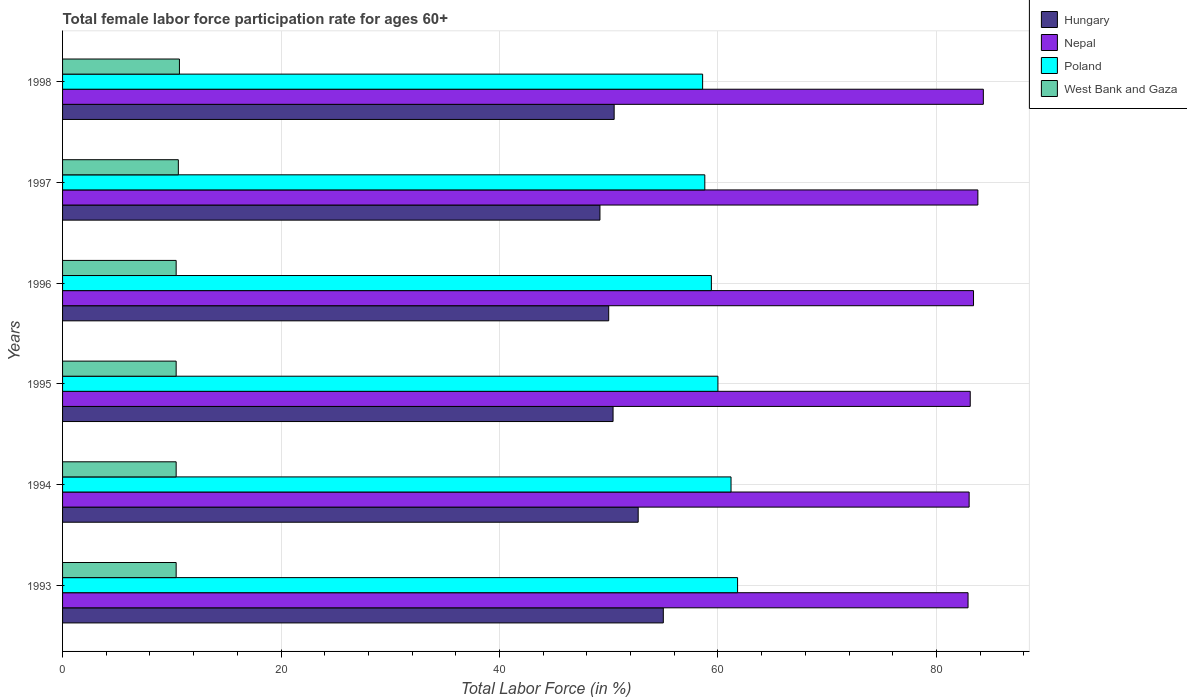Are the number of bars per tick equal to the number of legend labels?
Give a very brief answer. Yes. Are the number of bars on each tick of the Y-axis equal?
Your response must be concise. Yes. How many bars are there on the 4th tick from the top?
Offer a terse response. 4. What is the label of the 1st group of bars from the top?
Give a very brief answer. 1998. In how many cases, is the number of bars for a given year not equal to the number of legend labels?
Your answer should be compact. 0. What is the female labor force participation rate in Hungary in 1993?
Keep it short and to the point. 55. Across all years, what is the minimum female labor force participation rate in Hungary?
Ensure brevity in your answer.  49.2. What is the total female labor force participation rate in Hungary in the graph?
Provide a succinct answer. 307.8. What is the difference between the female labor force participation rate in West Bank and Gaza in 1997 and that in 1998?
Provide a succinct answer. -0.1. What is the difference between the female labor force participation rate in West Bank and Gaza in 1994 and the female labor force participation rate in Poland in 1993?
Your answer should be very brief. -51.4. What is the average female labor force participation rate in West Bank and Gaza per year?
Offer a terse response. 10.48. In the year 1993, what is the difference between the female labor force participation rate in Poland and female labor force participation rate in Hungary?
Your answer should be very brief. 6.8. In how many years, is the female labor force participation rate in Poland greater than 44 %?
Provide a succinct answer. 6. What is the ratio of the female labor force participation rate in Hungary in 1996 to that in 1998?
Provide a short and direct response. 0.99. Is the female labor force participation rate in Poland in 1995 less than that in 1997?
Provide a succinct answer. No. Is the difference between the female labor force participation rate in Poland in 1995 and 1997 greater than the difference between the female labor force participation rate in Hungary in 1995 and 1997?
Your answer should be compact. Yes. What is the difference between the highest and the second highest female labor force participation rate in Poland?
Provide a short and direct response. 0.6. What is the difference between the highest and the lowest female labor force participation rate in West Bank and Gaza?
Make the answer very short. 0.3. Is it the case that in every year, the sum of the female labor force participation rate in Nepal and female labor force participation rate in Hungary is greater than the sum of female labor force participation rate in West Bank and Gaza and female labor force participation rate in Poland?
Provide a short and direct response. Yes. What does the 1st bar from the top in 1996 represents?
Your response must be concise. West Bank and Gaza. Is it the case that in every year, the sum of the female labor force participation rate in Nepal and female labor force participation rate in West Bank and Gaza is greater than the female labor force participation rate in Hungary?
Give a very brief answer. Yes. What is the difference between two consecutive major ticks on the X-axis?
Offer a very short reply. 20. How are the legend labels stacked?
Give a very brief answer. Vertical. What is the title of the graph?
Offer a terse response. Total female labor force participation rate for ages 60+. Does "Kuwait" appear as one of the legend labels in the graph?
Give a very brief answer. No. What is the label or title of the X-axis?
Offer a terse response. Total Labor Force (in %). What is the label or title of the Y-axis?
Offer a very short reply. Years. What is the Total Labor Force (in %) of Hungary in 1993?
Your answer should be very brief. 55. What is the Total Labor Force (in %) in Nepal in 1993?
Your answer should be compact. 82.9. What is the Total Labor Force (in %) of Poland in 1993?
Provide a short and direct response. 61.8. What is the Total Labor Force (in %) in West Bank and Gaza in 1993?
Make the answer very short. 10.4. What is the Total Labor Force (in %) of Hungary in 1994?
Your answer should be compact. 52.7. What is the Total Labor Force (in %) in Poland in 1994?
Ensure brevity in your answer.  61.2. What is the Total Labor Force (in %) in West Bank and Gaza in 1994?
Offer a very short reply. 10.4. What is the Total Labor Force (in %) in Hungary in 1995?
Your answer should be compact. 50.4. What is the Total Labor Force (in %) of Nepal in 1995?
Provide a succinct answer. 83.1. What is the Total Labor Force (in %) in West Bank and Gaza in 1995?
Your answer should be compact. 10.4. What is the Total Labor Force (in %) of Nepal in 1996?
Your answer should be very brief. 83.4. What is the Total Labor Force (in %) of Poland in 1996?
Provide a short and direct response. 59.4. What is the Total Labor Force (in %) of West Bank and Gaza in 1996?
Your answer should be very brief. 10.4. What is the Total Labor Force (in %) of Hungary in 1997?
Your answer should be very brief. 49.2. What is the Total Labor Force (in %) in Nepal in 1997?
Offer a terse response. 83.8. What is the Total Labor Force (in %) in Poland in 1997?
Keep it short and to the point. 58.8. What is the Total Labor Force (in %) of West Bank and Gaza in 1997?
Offer a very short reply. 10.6. What is the Total Labor Force (in %) in Hungary in 1998?
Ensure brevity in your answer.  50.5. What is the Total Labor Force (in %) in Nepal in 1998?
Your answer should be compact. 84.3. What is the Total Labor Force (in %) in Poland in 1998?
Keep it short and to the point. 58.6. What is the Total Labor Force (in %) of West Bank and Gaza in 1998?
Offer a terse response. 10.7. Across all years, what is the maximum Total Labor Force (in %) in Nepal?
Offer a very short reply. 84.3. Across all years, what is the maximum Total Labor Force (in %) in Poland?
Your response must be concise. 61.8. Across all years, what is the maximum Total Labor Force (in %) in West Bank and Gaza?
Your response must be concise. 10.7. Across all years, what is the minimum Total Labor Force (in %) of Hungary?
Give a very brief answer. 49.2. Across all years, what is the minimum Total Labor Force (in %) in Nepal?
Your response must be concise. 82.9. Across all years, what is the minimum Total Labor Force (in %) of Poland?
Your answer should be compact. 58.6. Across all years, what is the minimum Total Labor Force (in %) of West Bank and Gaza?
Your answer should be very brief. 10.4. What is the total Total Labor Force (in %) in Hungary in the graph?
Offer a very short reply. 307.8. What is the total Total Labor Force (in %) in Nepal in the graph?
Keep it short and to the point. 500.5. What is the total Total Labor Force (in %) of Poland in the graph?
Keep it short and to the point. 359.8. What is the total Total Labor Force (in %) of West Bank and Gaza in the graph?
Keep it short and to the point. 62.9. What is the difference between the Total Labor Force (in %) of Nepal in 1993 and that in 1994?
Your response must be concise. -0.1. What is the difference between the Total Labor Force (in %) of Hungary in 1993 and that in 1995?
Keep it short and to the point. 4.6. What is the difference between the Total Labor Force (in %) in West Bank and Gaza in 1993 and that in 1995?
Ensure brevity in your answer.  0. What is the difference between the Total Labor Force (in %) of Nepal in 1993 and that in 1996?
Offer a terse response. -0.5. What is the difference between the Total Labor Force (in %) of Poland in 1993 and that in 1996?
Your answer should be compact. 2.4. What is the difference between the Total Labor Force (in %) of West Bank and Gaza in 1993 and that in 1996?
Ensure brevity in your answer.  0. What is the difference between the Total Labor Force (in %) of Hungary in 1993 and that in 1997?
Give a very brief answer. 5.8. What is the difference between the Total Labor Force (in %) in West Bank and Gaza in 1993 and that in 1997?
Provide a succinct answer. -0.2. What is the difference between the Total Labor Force (in %) of Nepal in 1993 and that in 1998?
Keep it short and to the point. -1.4. What is the difference between the Total Labor Force (in %) in Poland in 1994 and that in 1995?
Provide a short and direct response. 1.2. What is the difference between the Total Labor Force (in %) of Nepal in 1994 and that in 1996?
Your answer should be compact. -0.4. What is the difference between the Total Labor Force (in %) of Poland in 1994 and that in 1996?
Your response must be concise. 1.8. What is the difference between the Total Labor Force (in %) in West Bank and Gaza in 1994 and that in 1996?
Your response must be concise. 0. What is the difference between the Total Labor Force (in %) of Hungary in 1994 and that in 1997?
Provide a short and direct response. 3.5. What is the difference between the Total Labor Force (in %) in Nepal in 1994 and that in 1997?
Offer a very short reply. -0.8. What is the difference between the Total Labor Force (in %) in Poland in 1994 and that in 1997?
Your answer should be compact. 2.4. What is the difference between the Total Labor Force (in %) of Hungary in 1994 and that in 1998?
Provide a short and direct response. 2.2. What is the difference between the Total Labor Force (in %) of West Bank and Gaza in 1995 and that in 1996?
Provide a succinct answer. 0. What is the difference between the Total Labor Force (in %) of Nepal in 1995 and that in 1997?
Offer a terse response. -0.7. What is the difference between the Total Labor Force (in %) of Poland in 1995 and that in 1997?
Your response must be concise. 1.2. What is the difference between the Total Labor Force (in %) of Hungary in 1995 and that in 1998?
Give a very brief answer. -0.1. What is the difference between the Total Labor Force (in %) in Hungary in 1996 and that in 1997?
Give a very brief answer. 0.8. What is the difference between the Total Labor Force (in %) in Poland in 1996 and that in 1997?
Ensure brevity in your answer.  0.6. What is the difference between the Total Labor Force (in %) of West Bank and Gaza in 1996 and that in 1997?
Provide a short and direct response. -0.2. What is the difference between the Total Labor Force (in %) in Hungary in 1996 and that in 1998?
Make the answer very short. -0.5. What is the difference between the Total Labor Force (in %) in Nepal in 1996 and that in 1998?
Keep it short and to the point. -0.9. What is the difference between the Total Labor Force (in %) of Hungary in 1993 and the Total Labor Force (in %) of Poland in 1994?
Give a very brief answer. -6.2. What is the difference between the Total Labor Force (in %) in Hungary in 1993 and the Total Labor Force (in %) in West Bank and Gaza in 1994?
Offer a terse response. 44.6. What is the difference between the Total Labor Force (in %) in Nepal in 1993 and the Total Labor Force (in %) in Poland in 1994?
Provide a short and direct response. 21.7. What is the difference between the Total Labor Force (in %) of Nepal in 1993 and the Total Labor Force (in %) of West Bank and Gaza in 1994?
Your answer should be compact. 72.5. What is the difference between the Total Labor Force (in %) of Poland in 1993 and the Total Labor Force (in %) of West Bank and Gaza in 1994?
Your answer should be very brief. 51.4. What is the difference between the Total Labor Force (in %) of Hungary in 1993 and the Total Labor Force (in %) of Nepal in 1995?
Offer a very short reply. -28.1. What is the difference between the Total Labor Force (in %) of Hungary in 1993 and the Total Labor Force (in %) of Poland in 1995?
Your response must be concise. -5. What is the difference between the Total Labor Force (in %) of Hungary in 1993 and the Total Labor Force (in %) of West Bank and Gaza in 1995?
Provide a succinct answer. 44.6. What is the difference between the Total Labor Force (in %) of Nepal in 1993 and the Total Labor Force (in %) of Poland in 1995?
Ensure brevity in your answer.  22.9. What is the difference between the Total Labor Force (in %) in Nepal in 1993 and the Total Labor Force (in %) in West Bank and Gaza in 1995?
Keep it short and to the point. 72.5. What is the difference between the Total Labor Force (in %) in Poland in 1993 and the Total Labor Force (in %) in West Bank and Gaza in 1995?
Keep it short and to the point. 51.4. What is the difference between the Total Labor Force (in %) of Hungary in 1993 and the Total Labor Force (in %) of Nepal in 1996?
Give a very brief answer. -28.4. What is the difference between the Total Labor Force (in %) of Hungary in 1993 and the Total Labor Force (in %) of West Bank and Gaza in 1996?
Ensure brevity in your answer.  44.6. What is the difference between the Total Labor Force (in %) in Nepal in 1993 and the Total Labor Force (in %) in West Bank and Gaza in 1996?
Provide a succinct answer. 72.5. What is the difference between the Total Labor Force (in %) of Poland in 1993 and the Total Labor Force (in %) of West Bank and Gaza in 1996?
Make the answer very short. 51.4. What is the difference between the Total Labor Force (in %) in Hungary in 1993 and the Total Labor Force (in %) in Nepal in 1997?
Make the answer very short. -28.8. What is the difference between the Total Labor Force (in %) in Hungary in 1993 and the Total Labor Force (in %) in West Bank and Gaza in 1997?
Ensure brevity in your answer.  44.4. What is the difference between the Total Labor Force (in %) in Nepal in 1993 and the Total Labor Force (in %) in Poland in 1997?
Your answer should be compact. 24.1. What is the difference between the Total Labor Force (in %) in Nepal in 1993 and the Total Labor Force (in %) in West Bank and Gaza in 1997?
Offer a very short reply. 72.3. What is the difference between the Total Labor Force (in %) in Poland in 1993 and the Total Labor Force (in %) in West Bank and Gaza in 1997?
Your response must be concise. 51.2. What is the difference between the Total Labor Force (in %) of Hungary in 1993 and the Total Labor Force (in %) of Nepal in 1998?
Ensure brevity in your answer.  -29.3. What is the difference between the Total Labor Force (in %) of Hungary in 1993 and the Total Labor Force (in %) of West Bank and Gaza in 1998?
Keep it short and to the point. 44.3. What is the difference between the Total Labor Force (in %) of Nepal in 1993 and the Total Labor Force (in %) of Poland in 1998?
Ensure brevity in your answer.  24.3. What is the difference between the Total Labor Force (in %) of Nepal in 1993 and the Total Labor Force (in %) of West Bank and Gaza in 1998?
Offer a terse response. 72.2. What is the difference between the Total Labor Force (in %) in Poland in 1993 and the Total Labor Force (in %) in West Bank and Gaza in 1998?
Ensure brevity in your answer.  51.1. What is the difference between the Total Labor Force (in %) of Hungary in 1994 and the Total Labor Force (in %) of Nepal in 1995?
Offer a very short reply. -30.4. What is the difference between the Total Labor Force (in %) of Hungary in 1994 and the Total Labor Force (in %) of Poland in 1995?
Provide a short and direct response. -7.3. What is the difference between the Total Labor Force (in %) of Hungary in 1994 and the Total Labor Force (in %) of West Bank and Gaza in 1995?
Keep it short and to the point. 42.3. What is the difference between the Total Labor Force (in %) in Nepal in 1994 and the Total Labor Force (in %) in Poland in 1995?
Your response must be concise. 23. What is the difference between the Total Labor Force (in %) of Nepal in 1994 and the Total Labor Force (in %) of West Bank and Gaza in 1995?
Offer a terse response. 72.6. What is the difference between the Total Labor Force (in %) in Poland in 1994 and the Total Labor Force (in %) in West Bank and Gaza in 1995?
Your answer should be compact. 50.8. What is the difference between the Total Labor Force (in %) of Hungary in 1994 and the Total Labor Force (in %) of Nepal in 1996?
Your response must be concise. -30.7. What is the difference between the Total Labor Force (in %) of Hungary in 1994 and the Total Labor Force (in %) of Poland in 1996?
Offer a very short reply. -6.7. What is the difference between the Total Labor Force (in %) of Hungary in 1994 and the Total Labor Force (in %) of West Bank and Gaza in 1996?
Provide a succinct answer. 42.3. What is the difference between the Total Labor Force (in %) of Nepal in 1994 and the Total Labor Force (in %) of Poland in 1996?
Your answer should be very brief. 23.6. What is the difference between the Total Labor Force (in %) of Nepal in 1994 and the Total Labor Force (in %) of West Bank and Gaza in 1996?
Provide a short and direct response. 72.6. What is the difference between the Total Labor Force (in %) of Poland in 1994 and the Total Labor Force (in %) of West Bank and Gaza in 1996?
Provide a short and direct response. 50.8. What is the difference between the Total Labor Force (in %) of Hungary in 1994 and the Total Labor Force (in %) of Nepal in 1997?
Provide a short and direct response. -31.1. What is the difference between the Total Labor Force (in %) in Hungary in 1994 and the Total Labor Force (in %) in Poland in 1997?
Offer a terse response. -6.1. What is the difference between the Total Labor Force (in %) in Hungary in 1994 and the Total Labor Force (in %) in West Bank and Gaza in 1997?
Provide a short and direct response. 42.1. What is the difference between the Total Labor Force (in %) in Nepal in 1994 and the Total Labor Force (in %) in Poland in 1997?
Give a very brief answer. 24.2. What is the difference between the Total Labor Force (in %) of Nepal in 1994 and the Total Labor Force (in %) of West Bank and Gaza in 1997?
Ensure brevity in your answer.  72.4. What is the difference between the Total Labor Force (in %) in Poland in 1994 and the Total Labor Force (in %) in West Bank and Gaza in 1997?
Keep it short and to the point. 50.6. What is the difference between the Total Labor Force (in %) in Hungary in 1994 and the Total Labor Force (in %) in Nepal in 1998?
Your answer should be very brief. -31.6. What is the difference between the Total Labor Force (in %) of Hungary in 1994 and the Total Labor Force (in %) of West Bank and Gaza in 1998?
Make the answer very short. 42. What is the difference between the Total Labor Force (in %) of Nepal in 1994 and the Total Labor Force (in %) of Poland in 1998?
Keep it short and to the point. 24.4. What is the difference between the Total Labor Force (in %) of Nepal in 1994 and the Total Labor Force (in %) of West Bank and Gaza in 1998?
Your response must be concise. 72.3. What is the difference between the Total Labor Force (in %) of Poland in 1994 and the Total Labor Force (in %) of West Bank and Gaza in 1998?
Keep it short and to the point. 50.5. What is the difference between the Total Labor Force (in %) in Hungary in 1995 and the Total Labor Force (in %) in Nepal in 1996?
Your answer should be compact. -33. What is the difference between the Total Labor Force (in %) of Hungary in 1995 and the Total Labor Force (in %) of Poland in 1996?
Keep it short and to the point. -9. What is the difference between the Total Labor Force (in %) in Nepal in 1995 and the Total Labor Force (in %) in Poland in 1996?
Offer a terse response. 23.7. What is the difference between the Total Labor Force (in %) of Nepal in 1995 and the Total Labor Force (in %) of West Bank and Gaza in 1996?
Give a very brief answer. 72.7. What is the difference between the Total Labor Force (in %) of Poland in 1995 and the Total Labor Force (in %) of West Bank and Gaza in 1996?
Your answer should be very brief. 49.6. What is the difference between the Total Labor Force (in %) of Hungary in 1995 and the Total Labor Force (in %) of Nepal in 1997?
Your answer should be very brief. -33.4. What is the difference between the Total Labor Force (in %) of Hungary in 1995 and the Total Labor Force (in %) of West Bank and Gaza in 1997?
Make the answer very short. 39.8. What is the difference between the Total Labor Force (in %) in Nepal in 1995 and the Total Labor Force (in %) in Poland in 1997?
Offer a very short reply. 24.3. What is the difference between the Total Labor Force (in %) of Nepal in 1995 and the Total Labor Force (in %) of West Bank and Gaza in 1997?
Keep it short and to the point. 72.5. What is the difference between the Total Labor Force (in %) of Poland in 1995 and the Total Labor Force (in %) of West Bank and Gaza in 1997?
Provide a short and direct response. 49.4. What is the difference between the Total Labor Force (in %) in Hungary in 1995 and the Total Labor Force (in %) in Nepal in 1998?
Your answer should be compact. -33.9. What is the difference between the Total Labor Force (in %) in Hungary in 1995 and the Total Labor Force (in %) in Poland in 1998?
Your answer should be very brief. -8.2. What is the difference between the Total Labor Force (in %) in Hungary in 1995 and the Total Labor Force (in %) in West Bank and Gaza in 1998?
Offer a very short reply. 39.7. What is the difference between the Total Labor Force (in %) in Nepal in 1995 and the Total Labor Force (in %) in Poland in 1998?
Give a very brief answer. 24.5. What is the difference between the Total Labor Force (in %) of Nepal in 1995 and the Total Labor Force (in %) of West Bank and Gaza in 1998?
Your answer should be very brief. 72.4. What is the difference between the Total Labor Force (in %) in Poland in 1995 and the Total Labor Force (in %) in West Bank and Gaza in 1998?
Your answer should be compact. 49.3. What is the difference between the Total Labor Force (in %) in Hungary in 1996 and the Total Labor Force (in %) in Nepal in 1997?
Make the answer very short. -33.8. What is the difference between the Total Labor Force (in %) of Hungary in 1996 and the Total Labor Force (in %) of West Bank and Gaza in 1997?
Your response must be concise. 39.4. What is the difference between the Total Labor Force (in %) of Nepal in 1996 and the Total Labor Force (in %) of Poland in 1997?
Offer a terse response. 24.6. What is the difference between the Total Labor Force (in %) of Nepal in 1996 and the Total Labor Force (in %) of West Bank and Gaza in 1997?
Provide a short and direct response. 72.8. What is the difference between the Total Labor Force (in %) in Poland in 1996 and the Total Labor Force (in %) in West Bank and Gaza in 1997?
Offer a terse response. 48.8. What is the difference between the Total Labor Force (in %) of Hungary in 1996 and the Total Labor Force (in %) of Nepal in 1998?
Your answer should be very brief. -34.3. What is the difference between the Total Labor Force (in %) of Hungary in 1996 and the Total Labor Force (in %) of Poland in 1998?
Provide a short and direct response. -8.6. What is the difference between the Total Labor Force (in %) of Hungary in 1996 and the Total Labor Force (in %) of West Bank and Gaza in 1998?
Keep it short and to the point. 39.3. What is the difference between the Total Labor Force (in %) in Nepal in 1996 and the Total Labor Force (in %) in Poland in 1998?
Ensure brevity in your answer.  24.8. What is the difference between the Total Labor Force (in %) in Nepal in 1996 and the Total Labor Force (in %) in West Bank and Gaza in 1998?
Keep it short and to the point. 72.7. What is the difference between the Total Labor Force (in %) in Poland in 1996 and the Total Labor Force (in %) in West Bank and Gaza in 1998?
Provide a succinct answer. 48.7. What is the difference between the Total Labor Force (in %) of Hungary in 1997 and the Total Labor Force (in %) of Nepal in 1998?
Your answer should be compact. -35.1. What is the difference between the Total Labor Force (in %) of Hungary in 1997 and the Total Labor Force (in %) of Poland in 1998?
Your answer should be very brief. -9.4. What is the difference between the Total Labor Force (in %) in Hungary in 1997 and the Total Labor Force (in %) in West Bank and Gaza in 1998?
Offer a very short reply. 38.5. What is the difference between the Total Labor Force (in %) of Nepal in 1997 and the Total Labor Force (in %) of Poland in 1998?
Your answer should be very brief. 25.2. What is the difference between the Total Labor Force (in %) of Nepal in 1997 and the Total Labor Force (in %) of West Bank and Gaza in 1998?
Provide a short and direct response. 73.1. What is the difference between the Total Labor Force (in %) of Poland in 1997 and the Total Labor Force (in %) of West Bank and Gaza in 1998?
Offer a terse response. 48.1. What is the average Total Labor Force (in %) of Hungary per year?
Your answer should be very brief. 51.3. What is the average Total Labor Force (in %) of Nepal per year?
Offer a very short reply. 83.42. What is the average Total Labor Force (in %) of Poland per year?
Your answer should be very brief. 59.97. What is the average Total Labor Force (in %) in West Bank and Gaza per year?
Offer a very short reply. 10.48. In the year 1993, what is the difference between the Total Labor Force (in %) in Hungary and Total Labor Force (in %) in Nepal?
Your answer should be very brief. -27.9. In the year 1993, what is the difference between the Total Labor Force (in %) in Hungary and Total Labor Force (in %) in Poland?
Keep it short and to the point. -6.8. In the year 1993, what is the difference between the Total Labor Force (in %) in Hungary and Total Labor Force (in %) in West Bank and Gaza?
Offer a terse response. 44.6. In the year 1993, what is the difference between the Total Labor Force (in %) of Nepal and Total Labor Force (in %) of Poland?
Your answer should be very brief. 21.1. In the year 1993, what is the difference between the Total Labor Force (in %) in Nepal and Total Labor Force (in %) in West Bank and Gaza?
Give a very brief answer. 72.5. In the year 1993, what is the difference between the Total Labor Force (in %) of Poland and Total Labor Force (in %) of West Bank and Gaza?
Provide a short and direct response. 51.4. In the year 1994, what is the difference between the Total Labor Force (in %) of Hungary and Total Labor Force (in %) of Nepal?
Give a very brief answer. -30.3. In the year 1994, what is the difference between the Total Labor Force (in %) of Hungary and Total Labor Force (in %) of Poland?
Make the answer very short. -8.5. In the year 1994, what is the difference between the Total Labor Force (in %) in Hungary and Total Labor Force (in %) in West Bank and Gaza?
Offer a very short reply. 42.3. In the year 1994, what is the difference between the Total Labor Force (in %) of Nepal and Total Labor Force (in %) of Poland?
Provide a succinct answer. 21.8. In the year 1994, what is the difference between the Total Labor Force (in %) in Nepal and Total Labor Force (in %) in West Bank and Gaza?
Ensure brevity in your answer.  72.6. In the year 1994, what is the difference between the Total Labor Force (in %) in Poland and Total Labor Force (in %) in West Bank and Gaza?
Keep it short and to the point. 50.8. In the year 1995, what is the difference between the Total Labor Force (in %) of Hungary and Total Labor Force (in %) of Nepal?
Offer a terse response. -32.7. In the year 1995, what is the difference between the Total Labor Force (in %) in Nepal and Total Labor Force (in %) in Poland?
Your answer should be very brief. 23.1. In the year 1995, what is the difference between the Total Labor Force (in %) in Nepal and Total Labor Force (in %) in West Bank and Gaza?
Ensure brevity in your answer.  72.7. In the year 1995, what is the difference between the Total Labor Force (in %) of Poland and Total Labor Force (in %) of West Bank and Gaza?
Provide a succinct answer. 49.6. In the year 1996, what is the difference between the Total Labor Force (in %) in Hungary and Total Labor Force (in %) in Nepal?
Your answer should be very brief. -33.4. In the year 1996, what is the difference between the Total Labor Force (in %) of Hungary and Total Labor Force (in %) of West Bank and Gaza?
Provide a short and direct response. 39.6. In the year 1996, what is the difference between the Total Labor Force (in %) of Nepal and Total Labor Force (in %) of Poland?
Your answer should be compact. 24. In the year 1996, what is the difference between the Total Labor Force (in %) of Nepal and Total Labor Force (in %) of West Bank and Gaza?
Your response must be concise. 73. In the year 1997, what is the difference between the Total Labor Force (in %) of Hungary and Total Labor Force (in %) of Nepal?
Give a very brief answer. -34.6. In the year 1997, what is the difference between the Total Labor Force (in %) in Hungary and Total Labor Force (in %) in West Bank and Gaza?
Make the answer very short. 38.6. In the year 1997, what is the difference between the Total Labor Force (in %) in Nepal and Total Labor Force (in %) in Poland?
Offer a terse response. 25. In the year 1997, what is the difference between the Total Labor Force (in %) of Nepal and Total Labor Force (in %) of West Bank and Gaza?
Provide a short and direct response. 73.2. In the year 1997, what is the difference between the Total Labor Force (in %) of Poland and Total Labor Force (in %) of West Bank and Gaza?
Provide a succinct answer. 48.2. In the year 1998, what is the difference between the Total Labor Force (in %) of Hungary and Total Labor Force (in %) of Nepal?
Your response must be concise. -33.8. In the year 1998, what is the difference between the Total Labor Force (in %) in Hungary and Total Labor Force (in %) in Poland?
Provide a short and direct response. -8.1. In the year 1998, what is the difference between the Total Labor Force (in %) of Hungary and Total Labor Force (in %) of West Bank and Gaza?
Provide a short and direct response. 39.8. In the year 1998, what is the difference between the Total Labor Force (in %) of Nepal and Total Labor Force (in %) of Poland?
Your response must be concise. 25.7. In the year 1998, what is the difference between the Total Labor Force (in %) in Nepal and Total Labor Force (in %) in West Bank and Gaza?
Ensure brevity in your answer.  73.6. In the year 1998, what is the difference between the Total Labor Force (in %) of Poland and Total Labor Force (in %) of West Bank and Gaza?
Provide a short and direct response. 47.9. What is the ratio of the Total Labor Force (in %) in Hungary in 1993 to that in 1994?
Your answer should be compact. 1.04. What is the ratio of the Total Labor Force (in %) of Poland in 1993 to that in 1994?
Keep it short and to the point. 1.01. What is the ratio of the Total Labor Force (in %) of West Bank and Gaza in 1993 to that in 1994?
Your answer should be compact. 1. What is the ratio of the Total Labor Force (in %) of Hungary in 1993 to that in 1995?
Provide a short and direct response. 1.09. What is the ratio of the Total Labor Force (in %) in Nepal in 1993 to that in 1995?
Ensure brevity in your answer.  1. What is the ratio of the Total Labor Force (in %) in West Bank and Gaza in 1993 to that in 1995?
Provide a succinct answer. 1. What is the ratio of the Total Labor Force (in %) of Hungary in 1993 to that in 1996?
Give a very brief answer. 1.1. What is the ratio of the Total Labor Force (in %) of Nepal in 1993 to that in 1996?
Your response must be concise. 0.99. What is the ratio of the Total Labor Force (in %) in Poland in 1993 to that in 1996?
Provide a succinct answer. 1.04. What is the ratio of the Total Labor Force (in %) in Hungary in 1993 to that in 1997?
Keep it short and to the point. 1.12. What is the ratio of the Total Labor Force (in %) of Nepal in 1993 to that in 1997?
Your response must be concise. 0.99. What is the ratio of the Total Labor Force (in %) of Poland in 1993 to that in 1997?
Offer a terse response. 1.05. What is the ratio of the Total Labor Force (in %) in West Bank and Gaza in 1993 to that in 1997?
Offer a very short reply. 0.98. What is the ratio of the Total Labor Force (in %) of Hungary in 1993 to that in 1998?
Offer a very short reply. 1.09. What is the ratio of the Total Labor Force (in %) of Nepal in 1993 to that in 1998?
Ensure brevity in your answer.  0.98. What is the ratio of the Total Labor Force (in %) in Poland in 1993 to that in 1998?
Keep it short and to the point. 1.05. What is the ratio of the Total Labor Force (in %) of Hungary in 1994 to that in 1995?
Your answer should be very brief. 1.05. What is the ratio of the Total Labor Force (in %) of Nepal in 1994 to that in 1995?
Give a very brief answer. 1. What is the ratio of the Total Labor Force (in %) in Poland in 1994 to that in 1995?
Offer a very short reply. 1.02. What is the ratio of the Total Labor Force (in %) in Hungary in 1994 to that in 1996?
Give a very brief answer. 1.05. What is the ratio of the Total Labor Force (in %) in Nepal in 1994 to that in 1996?
Your answer should be compact. 1. What is the ratio of the Total Labor Force (in %) in Poland in 1994 to that in 1996?
Your answer should be compact. 1.03. What is the ratio of the Total Labor Force (in %) in Hungary in 1994 to that in 1997?
Provide a succinct answer. 1.07. What is the ratio of the Total Labor Force (in %) of Nepal in 1994 to that in 1997?
Provide a succinct answer. 0.99. What is the ratio of the Total Labor Force (in %) in Poland in 1994 to that in 1997?
Provide a succinct answer. 1.04. What is the ratio of the Total Labor Force (in %) in West Bank and Gaza in 1994 to that in 1997?
Provide a succinct answer. 0.98. What is the ratio of the Total Labor Force (in %) in Hungary in 1994 to that in 1998?
Your response must be concise. 1.04. What is the ratio of the Total Labor Force (in %) of Nepal in 1994 to that in 1998?
Offer a very short reply. 0.98. What is the ratio of the Total Labor Force (in %) of Poland in 1994 to that in 1998?
Provide a short and direct response. 1.04. What is the ratio of the Total Labor Force (in %) in West Bank and Gaza in 1994 to that in 1998?
Offer a terse response. 0.97. What is the ratio of the Total Labor Force (in %) of Hungary in 1995 to that in 1996?
Offer a very short reply. 1.01. What is the ratio of the Total Labor Force (in %) in Poland in 1995 to that in 1996?
Provide a succinct answer. 1.01. What is the ratio of the Total Labor Force (in %) of Hungary in 1995 to that in 1997?
Ensure brevity in your answer.  1.02. What is the ratio of the Total Labor Force (in %) in Poland in 1995 to that in 1997?
Your response must be concise. 1.02. What is the ratio of the Total Labor Force (in %) in West Bank and Gaza in 1995 to that in 1997?
Offer a very short reply. 0.98. What is the ratio of the Total Labor Force (in %) in Nepal in 1995 to that in 1998?
Provide a short and direct response. 0.99. What is the ratio of the Total Labor Force (in %) of Poland in 1995 to that in 1998?
Give a very brief answer. 1.02. What is the ratio of the Total Labor Force (in %) in West Bank and Gaza in 1995 to that in 1998?
Give a very brief answer. 0.97. What is the ratio of the Total Labor Force (in %) of Hungary in 1996 to that in 1997?
Offer a very short reply. 1.02. What is the ratio of the Total Labor Force (in %) in Nepal in 1996 to that in 1997?
Ensure brevity in your answer.  1. What is the ratio of the Total Labor Force (in %) in Poland in 1996 to that in 1997?
Your response must be concise. 1.01. What is the ratio of the Total Labor Force (in %) of West Bank and Gaza in 1996 to that in 1997?
Your answer should be compact. 0.98. What is the ratio of the Total Labor Force (in %) of Hungary in 1996 to that in 1998?
Provide a succinct answer. 0.99. What is the ratio of the Total Labor Force (in %) in Nepal in 1996 to that in 1998?
Give a very brief answer. 0.99. What is the ratio of the Total Labor Force (in %) in Poland in 1996 to that in 1998?
Make the answer very short. 1.01. What is the ratio of the Total Labor Force (in %) of West Bank and Gaza in 1996 to that in 1998?
Make the answer very short. 0.97. What is the ratio of the Total Labor Force (in %) in Hungary in 1997 to that in 1998?
Keep it short and to the point. 0.97. What is the ratio of the Total Labor Force (in %) of Nepal in 1997 to that in 1998?
Offer a terse response. 0.99. What is the ratio of the Total Labor Force (in %) in Poland in 1997 to that in 1998?
Ensure brevity in your answer.  1. What is the difference between the highest and the second highest Total Labor Force (in %) of Nepal?
Give a very brief answer. 0.5. What is the difference between the highest and the second highest Total Labor Force (in %) of Poland?
Your answer should be compact. 0.6. What is the difference between the highest and the second highest Total Labor Force (in %) of West Bank and Gaza?
Offer a very short reply. 0.1. What is the difference between the highest and the lowest Total Labor Force (in %) in Hungary?
Keep it short and to the point. 5.8. 